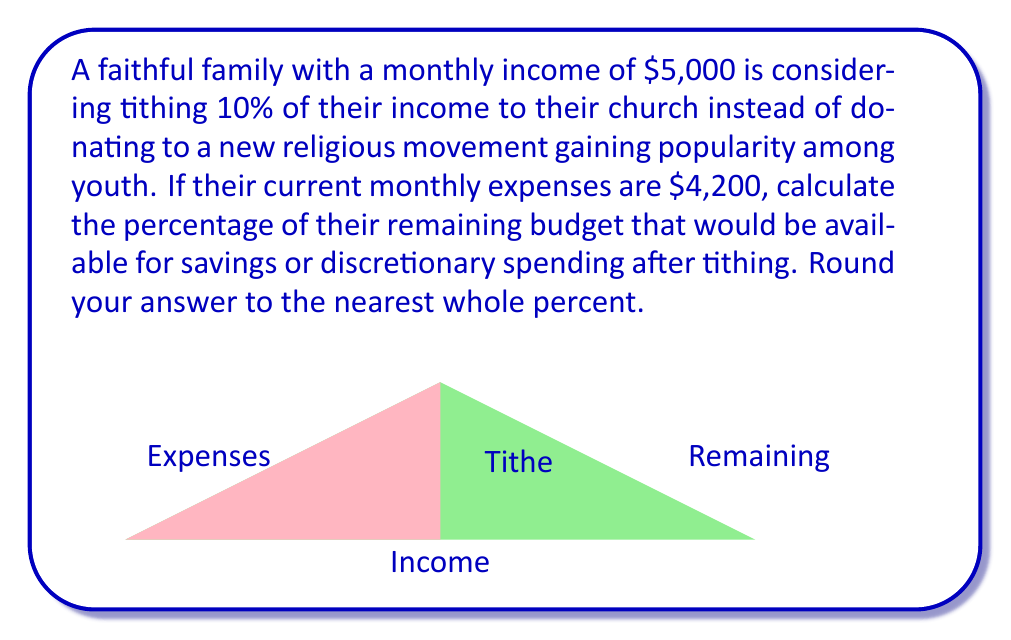Give your solution to this math problem. Let's approach this step-by-step:

1) First, calculate the tithe amount:
   $\text{Tithe} = 10\% \text{ of income} = 0.10 \times \$5,000 = \$500$

2) Calculate the remaining amount after tithing:
   $\text{Remaining after tithe} = \$5,000 - \$500 = \$4,500$

3) Subtract the current expenses from the remaining amount:
   $\text{Available for savings/discretionary} = \$4,500 - \$4,200 = \$300$

4) Calculate the percentage of the remaining budget:
   $$\text{Percentage} = \frac{\text{Available amount}}{\text{Remaining after tithe}} \times 100\%$$
   $$= \frac{\$300}{\$4,500} \times 100\% = 0.0667 \times 100\% = 6.67\%$$

5) Rounding to the nearest whole percent:
   $6.67\%$ rounds to $7\%$

This calculation shows that after tithing and paying expenses, the family would have 7% of their post-tithe budget available for savings or discretionary spending.
Answer: 7% 